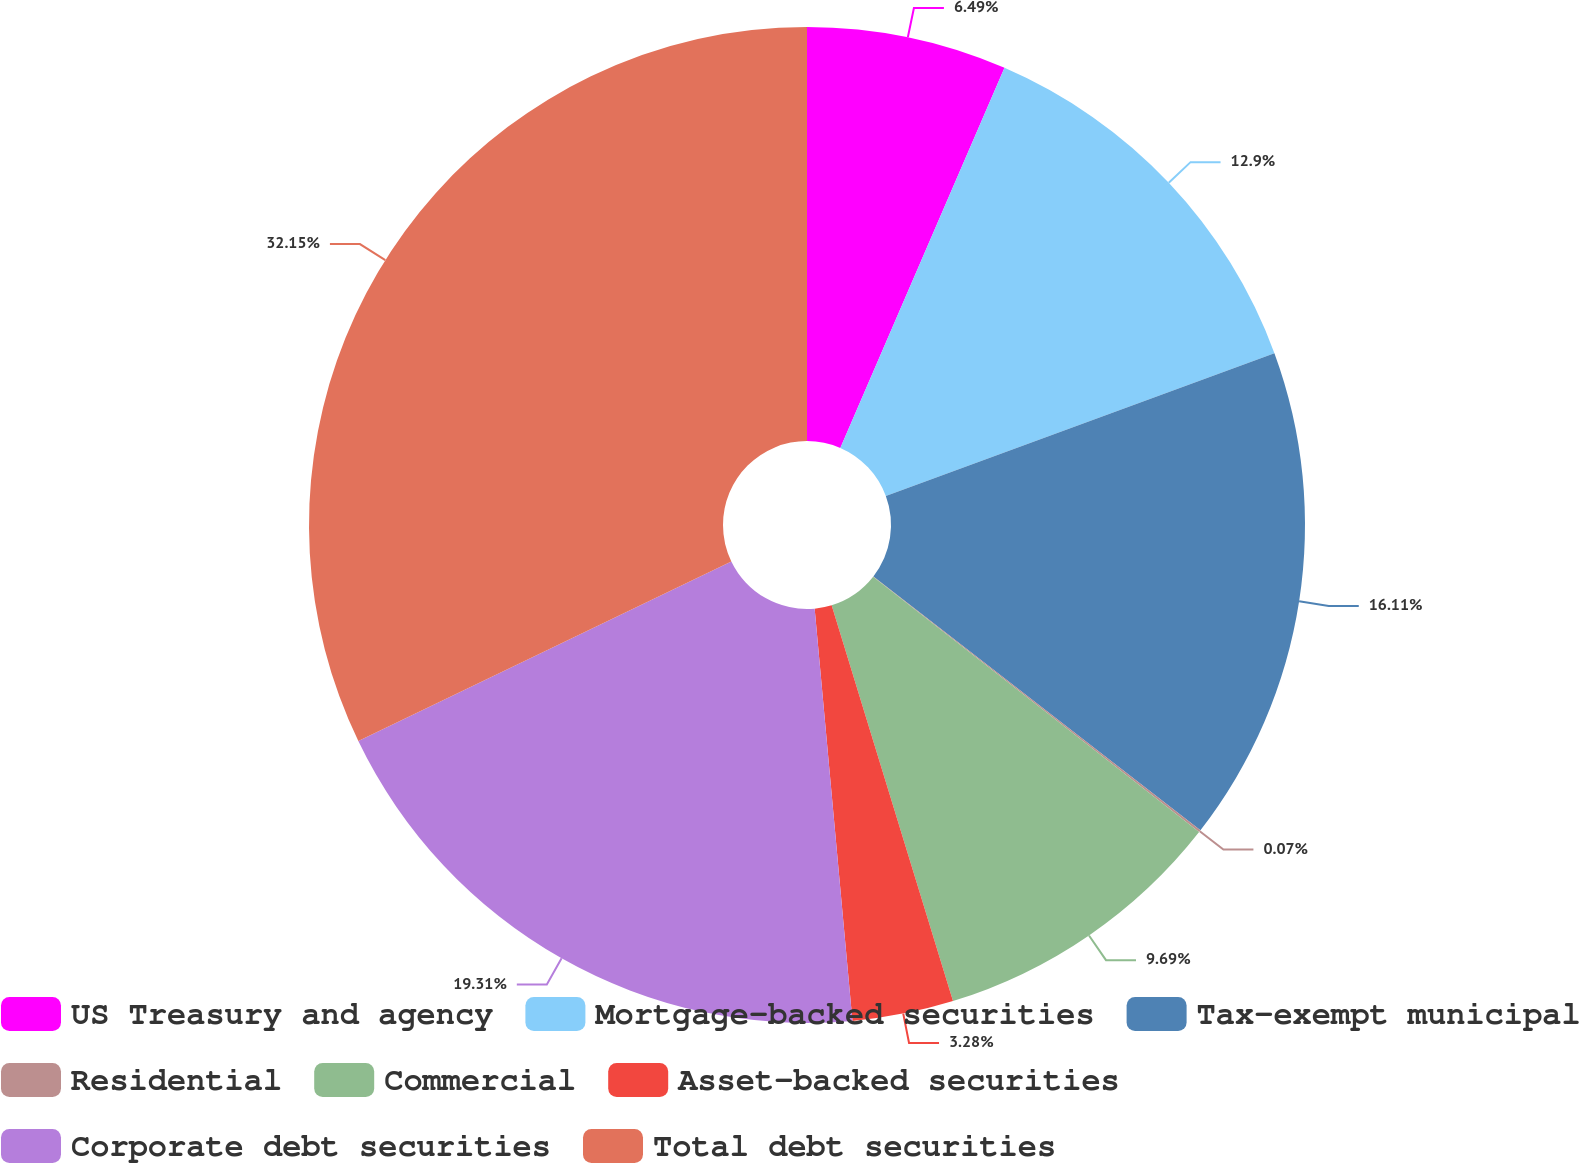<chart> <loc_0><loc_0><loc_500><loc_500><pie_chart><fcel>US Treasury and agency<fcel>Mortgage-backed securities<fcel>Tax-exempt municipal<fcel>Residential<fcel>Commercial<fcel>Asset-backed securities<fcel>Corporate debt securities<fcel>Total debt securities<nl><fcel>6.49%<fcel>12.9%<fcel>16.11%<fcel>0.07%<fcel>9.69%<fcel>3.28%<fcel>19.31%<fcel>32.14%<nl></chart> 